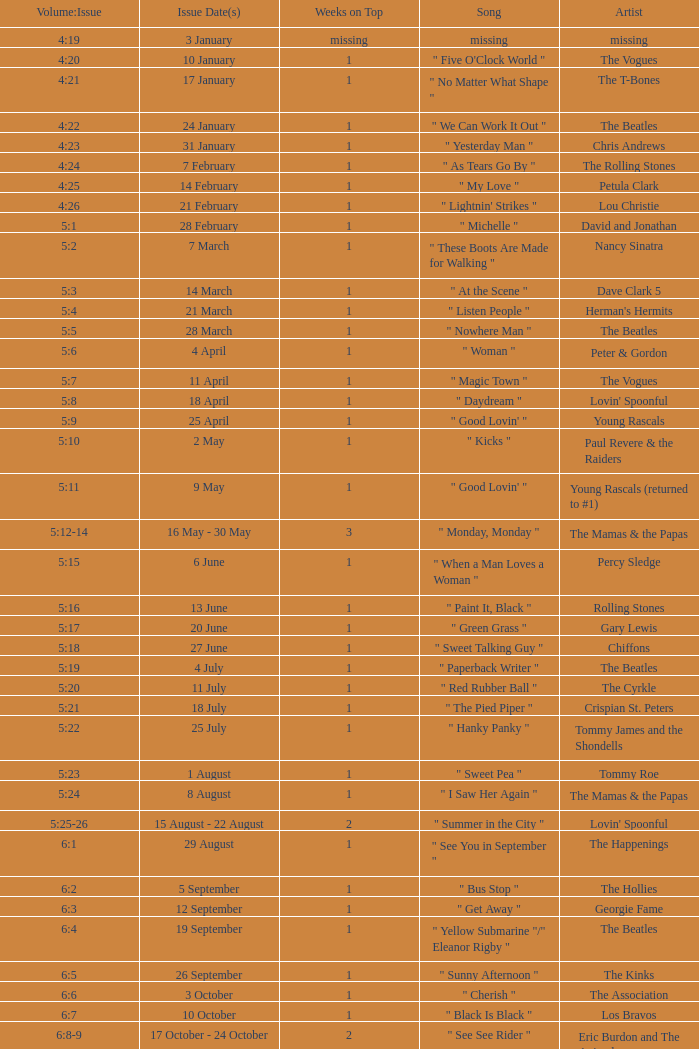Could you parse the entire table? {'header': ['Volume:Issue', 'Issue Date(s)', 'Weeks on Top', 'Song', 'Artist'], 'rows': [['4:19', '3 January', 'missing', 'missing', 'missing'], ['4:20', '10 January', '1', '" Five O\'Clock World "', 'The Vogues'], ['4:21', '17 January', '1', '" No Matter What Shape "', 'The T-Bones'], ['4:22', '24 January', '1', '" We Can Work It Out "', 'The Beatles'], ['4:23', '31 January', '1', '" Yesterday Man "', 'Chris Andrews'], ['4:24', '7 February', '1', '" As Tears Go By "', 'The Rolling Stones'], ['4:25', '14 February', '1', '" My Love "', 'Petula Clark'], ['4:26', '21 February', '1', '" Lightnin\' Strikes "', 'Lou Christie'], ['5:1', '28 February', '1', '" Michelle "', 'David and Jonathan'], ['5:2', '7 March', '1', '" These Boots Are Made for Walking "', 'Nancy Sinatra'], ['5:3', '14 March', '1', '" At the Scene "', 'Dave Clark 5'], ['5:4', '21 March', '1', '" Listen People "', "Herman's Hermits"], ['5:5', '28 March', '1', '" Nowhere Man "', 'The Beatles'], ['5:6', '4 April', '1', '" Woman "', 'Peter & Gordon'], ['5:7', '11 April', '1', '" Magic Town "', 'The Vogues'], ['5:8', '18 April', '1', '" Daydream "', "Lovin' Spoonful"], ['5:9', '25 April', '1', '" Good Lovin\' "', 'Young Rascals'], ['5:10', '2 May', '1', '" Kicks "', 'Paul Revere & the Raiders'], ['5:11', '9 May', '1', '" Good Lovin\' "', 'Young Rascals (returned to #1)'], ['5:12-14', '16 May - 30 May', '3', '" Monday, Monday "', 'The Mamas & the Papas'], ['5:15', '6 June', '1', '" When a Man Loves a Woman "', 'Percy Sledge'], ['5:16', '13 June', '1', '" Paint It, Black "', 'Rolling Stones'], ['5:17', '20 June', '1', '" Green Grass "', 'Gary Lewis'], ['5:18', '27 June', '1', '" Sweet Talking Guy "', 'Chiffons'], ['5:19', '4 July', '1', '" Paperback Writer "', 'The Beatles'], ['5:20', '11 July', '1', '" Red Rubber Ball "', 'The Cyrkle'], ['5:21', '18 July', '1', '" The Pied Piper "', 'Crispian St. Peters'], ['5:22', '25 July', '1', '" Hanky Panky "', 'Tommy James and the Shondells'], ['5:23', '1 August', '1', '" Sweet Pea "', 'Tommy Roe'], ['5:24', '8 August', '1', '" I Saw Her Again "', 'The Mamas & the Papas'], ['5:25-26', '15 August - 22 August', '2', '" Summer in the City "', "Lovin' Spoonful"], ['6:1', '29 August', '1', '" See You in September "', 'The Happenings'], ['6:2', '5 September', '1', '" Bus Stop "', 'The Hollies'], ['6:3', '12 September', '1', '" Get Away "', 'Georgie Fame'], ['6:4', '19 September', '1', '" Yellow Submarine "/" Eleanor Rigby "', 'The Beatles'], ['6:5', '26 September', '1', '" Sunny Afternoon "', 'The Kinks'], ['6:6', '3 October', '1', '" Cherish "', 'The Association'], ['6:7', '10 October', '1', '" Black Is Black "', 'Los Bravos'], ['6:8-9', '17 October - 24 October', '2', '" See See Rider "', 'Eric Burdon and The Animals'], ['6:10', '31 October', '1', '" 96 Tears "', 'Question Mark & the Mysterians'], ['6:11', '7 November', '1', '" Last Train to Clarksville "', 'The Monkees'], ['6:12', '14 November', '1', '" Dandy "', "Herman's Hermits"], ['6:13', '21 November', '1', '" Poor Side of Town "', 'Johnny Rivers'], ['6:14-15', '28 November - 5 December', '2', '" Winchester Cathedral "', 'New Vaudeville Band'], ['6:16', '12 December', '1', '" Lady Godiva "', 'Peter & Gordon'], ['6:17', '19 December', '1', '" Stop! Stop! Stop! "', 'The Hollies'], ['6:18-19', '26 December - 2 January', '2', '" I\'m a Believer "', 'The Monkees']]} A beatles artist with a release date(s) of 19 september has what as the recorded weeks at the peak? 1.0. 